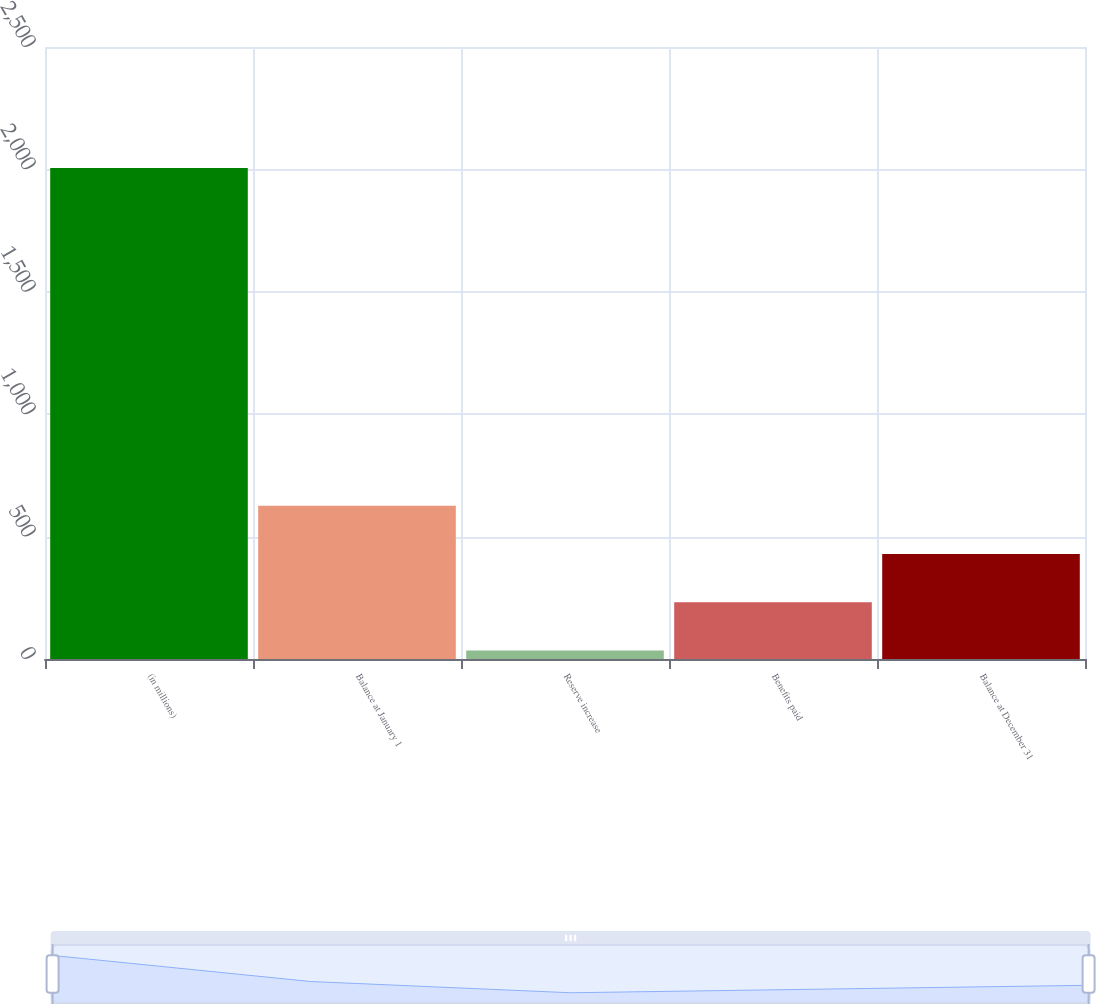Convert chart to OTSL. <chart><loc_0><loc_0><loc_500><loc_500><bar_chart><fcel>(in millions)<fcel>Balance at January 1<fcel>Reserve increase<fcel>Benefits paid<fcel>Balance at December 31<nl><fcel>2006<fcel>626.3<fcel>35<fcel>232.1<fcel>429.2<nl></chart> 